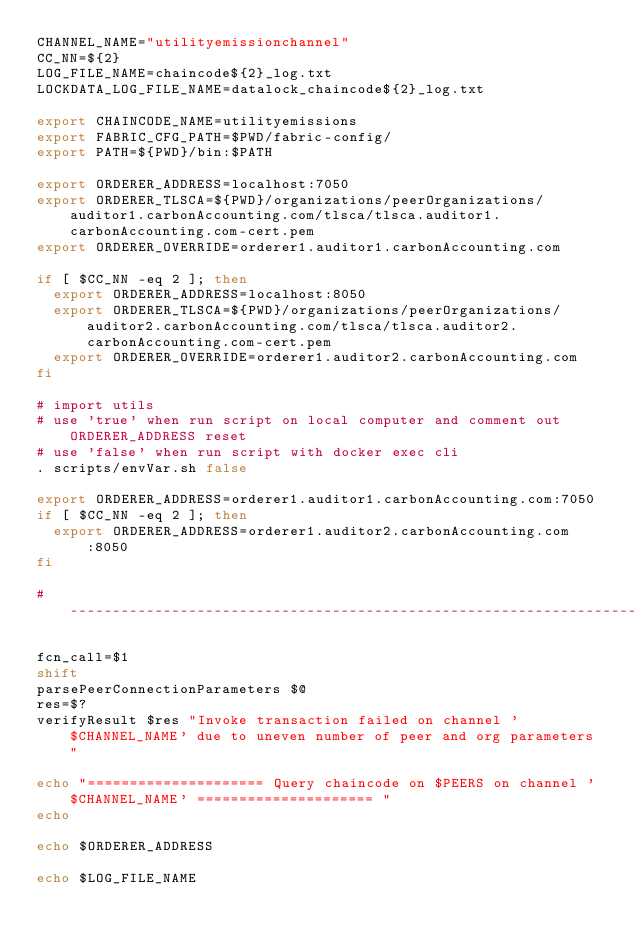<code> <loc_0><loc_0><loc_500><loc_500><_Bash_>CHANNEL_NAME="utilityemissionchannel"
CC_NN=${2}
LOG_FILE_NAME=chaincode${2}_log.txt
LOCKDATA_LOG_FILE_NAME=datalock_chaincode${2}_log.txt

export CHAINCODE_NAME=utilityemissions
export FABRIC_CFG_PATH=$PWD/fabric-config/
export PATH=${PWD}/bin:$PATH

export ORDERER_ADDRESS=localhost:7050
export ORDERER_TLSCA=${PWD}/organizations/peerOrganizations/auditor1.carbonAccounting.com/tlsca/tlsca.auditor1.carbonAccounting.com-cert.pem
export ORDERER_OVERRIDE=orderer1.auditor1.carbonAccounting.com

if [ $CC_NN -eq 2 ]; then
  export ORDERER_ADDRESS=localhost:8050
  export ORDERER_TLSCA=${PWD}/organizations/peerOrganizations/auditor2.carbonAccounting.com/tlsca/tlsca.auditor2.carbonAccounting.com-cert.pem
  export ORDERER_OVERRIDE=orderer1.auditor2.carbonAccounting.com
fi

# import utils
# use 'true' when run script on local computer and comment out ORDERER_ADDRESS reset
# use 'false' when run script with docker exec cli
. scripts/envVar.sh false

export ORDERER_ADDRESS=orderer1.auditor1.carbonAccounting.com:7050
if [ $CC_NN -eq 2 ]; then
  export ORDERER_ADDRESS=orderer1.auditor2.carbonAccounting.com:8050
fi

#-------------------------------------------------------------------

fcn_call=$1
shift
parsePeerConnectionParameters $@
res=$?
verifyResult $res "Invoke transaction failed on channel '$CHANNEL_NAME' due to uneven number of peer and org parameters "

echo "===================== Query chaincode on $PEERS on channel '$CHANNEL_NAME' ===================== "
echo

echo $ORDERER_ADDRESS

echo $LOG_FILE_NAME</code> 